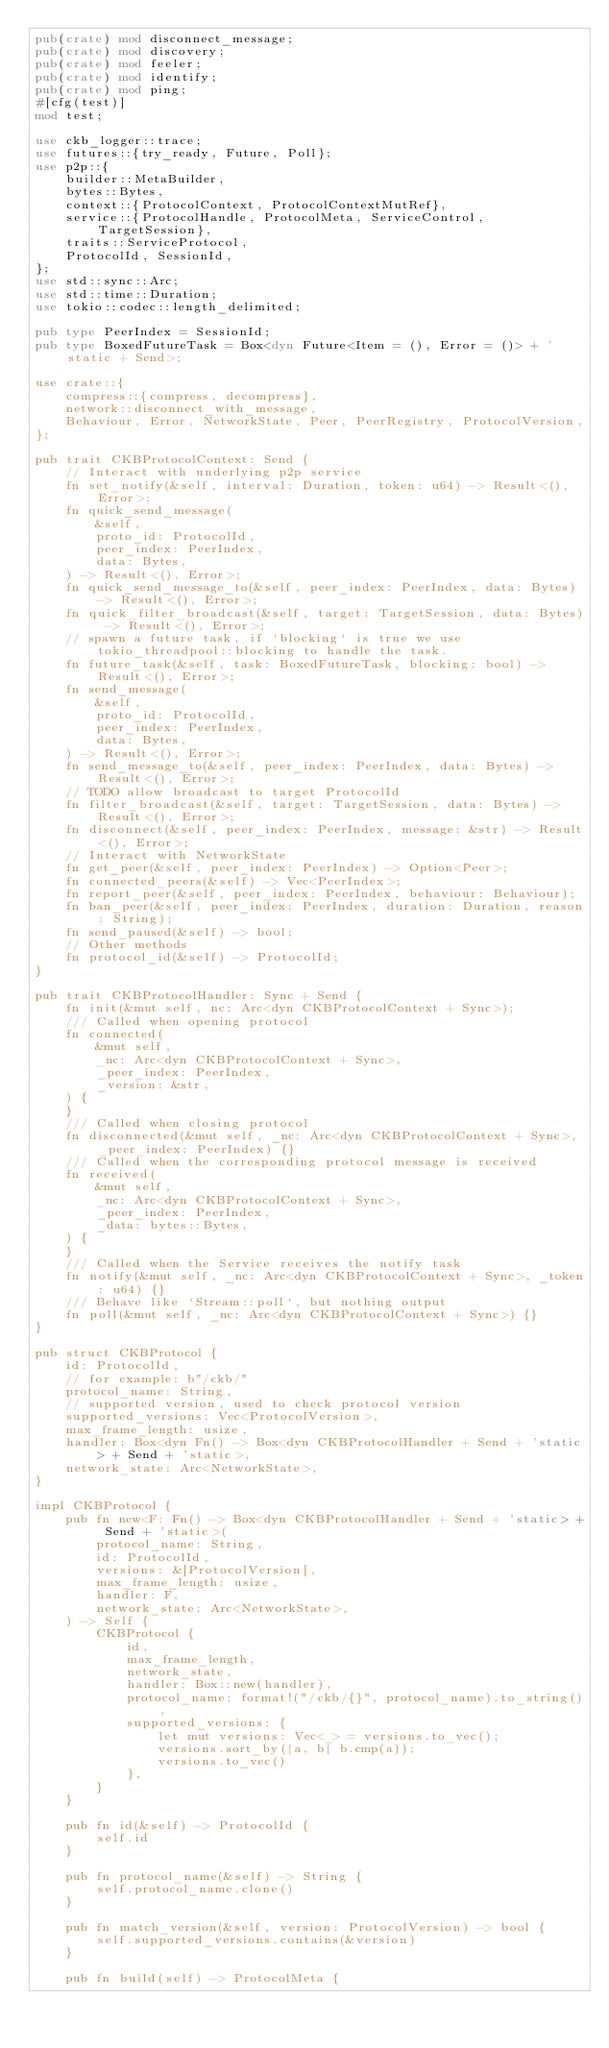Convert code to text. <code><loc_0><loc_0><loc_500><loc_500><_Rust_>pub(crate) mod disconnect_message;
pub(crate) mod discovery;
pub(crate) mod feeler;
pub(crate) mod identify;
pub(crate) mod ping;
#[cfg(test)]
mod test;

use ckb_logger::trace;
use futures::{try_ready, Future, Poll};
use p2p::{
    builder::MetaBuilder,
    bytes::Bytes,
    context::{ProtocolContext, ProtocolContextMutRef},
    service::{ProtocolHandle, ProtocolMeta, ServiceControl, TargetSession},
    traits::ServiceProtocol,
    ProtocolId, SessionId,
};
use std::sync::Arc;
use std::time::Duration;
use tokio::codec::length_delimited;

pub type PeerIndex = SessionId;
pub type BoxedFutureTask = Box<dyn Future<Item = (), Error = ()> + 'static + Send>;

use crate::{
    compress::{compress, decompress},
    network::disconnect_with_message,
    Behaviour, Error, NetworkState, Peer, PeerRegistry, ProtocolVersion,
};

pub trait CKBProtocolContext: Send {
    // Interact with underlying p2p service
    fn set_notify(&self, interval: Duration, token: u64) -> Result<(), Error>;
    fn quick_send_message(
        &self,
        proto_id: ProtocolId,
        peer_index: PeerIndex,
        data: Bytes,
    ) -> Result<(), Error>;
    fn quick_send_message_to(&self, peer_index: PeerIndex, data: Bytes) -> Result<(), Error>;
    fn quick_filter_broadcast(&self, target: TargetSession, data: Bytes) -> Result<(), Error>;
    // spawn a future task, if `blocking` is true we use tokio_threadpool::blocking to handle the task.
    fn future_task(&self, task: BoxedFutureTask, blocking: bool) -> Result<(), Error>;
    fn send_message(
        &self,
        proto_id: ProtocolId,
        peer_index: PeerIndex,
        data: Bytes,
    ) -> Result<(), Error>;
    fn send_message_to(&self, peer_index: PeerIndex, data: Bytes) -> Result<(), Error>;
    // TODO allow broadcast to target ProtocolId
    fn filter_broadcast(&self, target: TargetSession, data: Bytes) -> Result<(), Error>;
    fn disconnect(&self, peer_index: PeerIndex, message: &str) -> Result<(), Error>;
    // Interact with NetworkState
    fn get_peer(&self, peer_index: PeerIndex) -> Option<Peer>;
    fn connected_peers(&self) -> Vec<PeerIndex>;
    fn report_peer(&self, peer_index: PeerIndex, behaviour: Behaviour);
    fn ban_peer(&self, peer_index: PeerIndex, duration: Duration, reason: String);
    fn send_paused(&self) -> bool;
    // Other methods
    fn protocol_id(&self) -> ProtocolId;
}

pub trait CKBProtocolHandler: Sync + Send {
    fn init(&mut self, nc: Arc<dyn CKBProtocolContext + Sync>);
    /// Called when opening protocol
    fn connected(
        &mut self,
        _nc: Arc<dyn CKBProtocolContext + Sync>,
        _peer_index: PeerIndex,
        _version: &str,
    ) {
    }
    /// Called when closing protocol
    fn disconnected(&mut self, _nc: Arc<dyn CKBProtocolContext + Sync>, _peer_index: PeerIndex) {}
    /// Called when the corresponding protocol message is received
    fn received(
        &mut self,
        _nc: Arc<dyn CKBProtocolContext + Sync>,
        _peer_index: PeerIndex,
        _data: bytes::Bytes,
    ) {
    }
    /// Called when the Service receives the notify task
    fn notify(&mut self, _nc: Arc<dyn CKBProtocolContext + Sync>, _token: u64) {}
    /// Behave like `Stream::poll`, but nothing output
    fn poll(&mut self, _nc: Arc<dyn CKBProtocolContext + Sync>) {}
}

pub struct CKBProtocol {
    id: ProtocolId,
    // for example: b"/ckb/"
    protocol_name: String,
    // supported version, used to check protocol version
    supported_versions: Vec<ProtocolVersion>,
    max_frame_length: usize,
    handler: Box<dyn Fn() -> Box<dyn CKBProtocolHandler + Send + 'static> + Send + 'static>,
    network_state: Arc<NetworkState>,
}

impl CKBProtocol {
    pub fn new<F: Fn() -> Box<dyn CKBProtocolHandler + Send + 'static> + Send + 'static>(
        protocol_name: String,
        id: ProtocolId,
        versions: &[ProtocolVersion],
        max_frame_length: usize,
        handler: F,
        network_state: Arc<NetworkState>,
    ) -> Self {
        CKBProtocol {
            id,
            max_frame_length,
            network_state,
            handler: Box::new(handler),
            protocol_name: format!("/ckb/{}", protocol_name).to_string(),
            supported_versions: {
                let mut versions: Vec<_> = versions.to_vec();
                versions.sort_by(|a, b| b.cmp(a));
                versions.to_vec()
            },
        }
    }

    pub fn id(&self) -> ProtocolId {
        self.id
    }

    pub fn protocol_name(&self) -> String {
        self.protocol_name.clone()
    }

    pub fn match_version(&self, version: ProtocolVersion) -> bool {
        self.supported_versions.contains(&version)
    }

    pub fn build(self) -> ProtocolMeta {</code> 